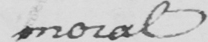What is written in this line of handwriting? moral 